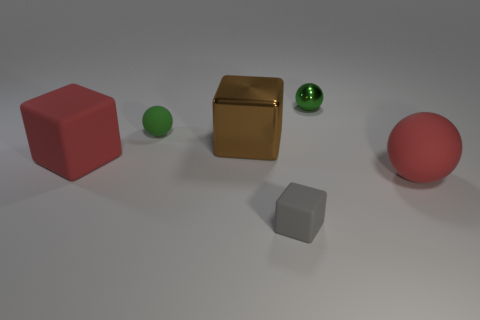How many objects are either green matte spheres or rubber spheres that are on the left side of the brown metallic block? Upon examining the image, it appears there is one green matte sphere situated to the immediate left of the brown metallic block. Regarding rubber spheres, there are no discernible features in the image that indicate the material composition of the spheres to confidently classify any as 'rubber.' Therefore, the accurate count of the objects meeting the described criteria is one. 